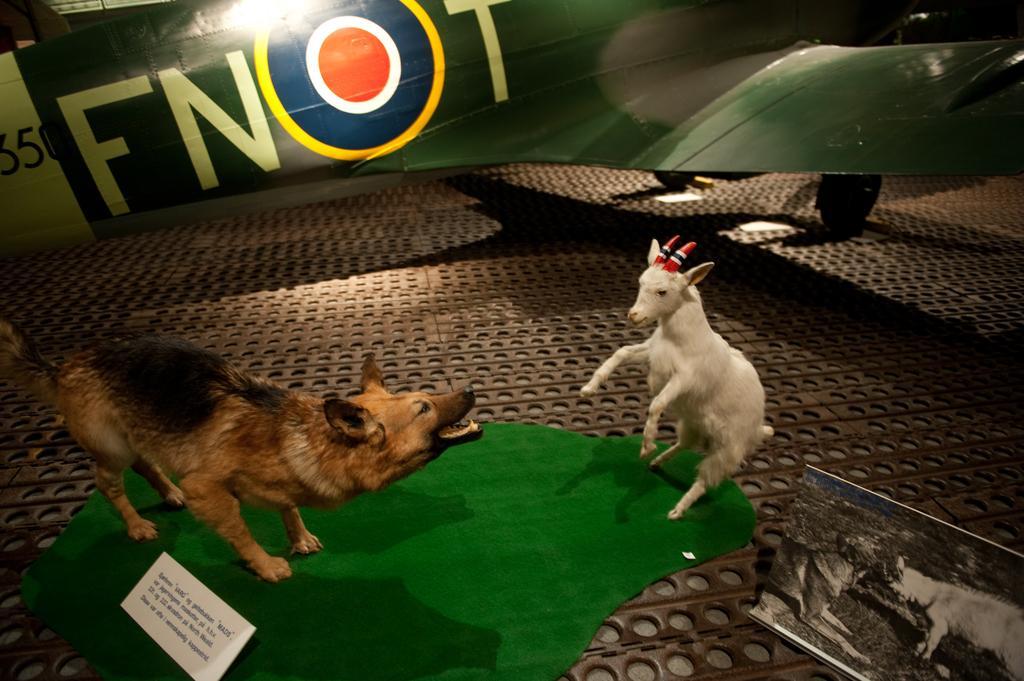How would you summarize this image in a sentence or two? In this image, we can see two animals, there is a green cloth on the floor, we can see an aircraft. 